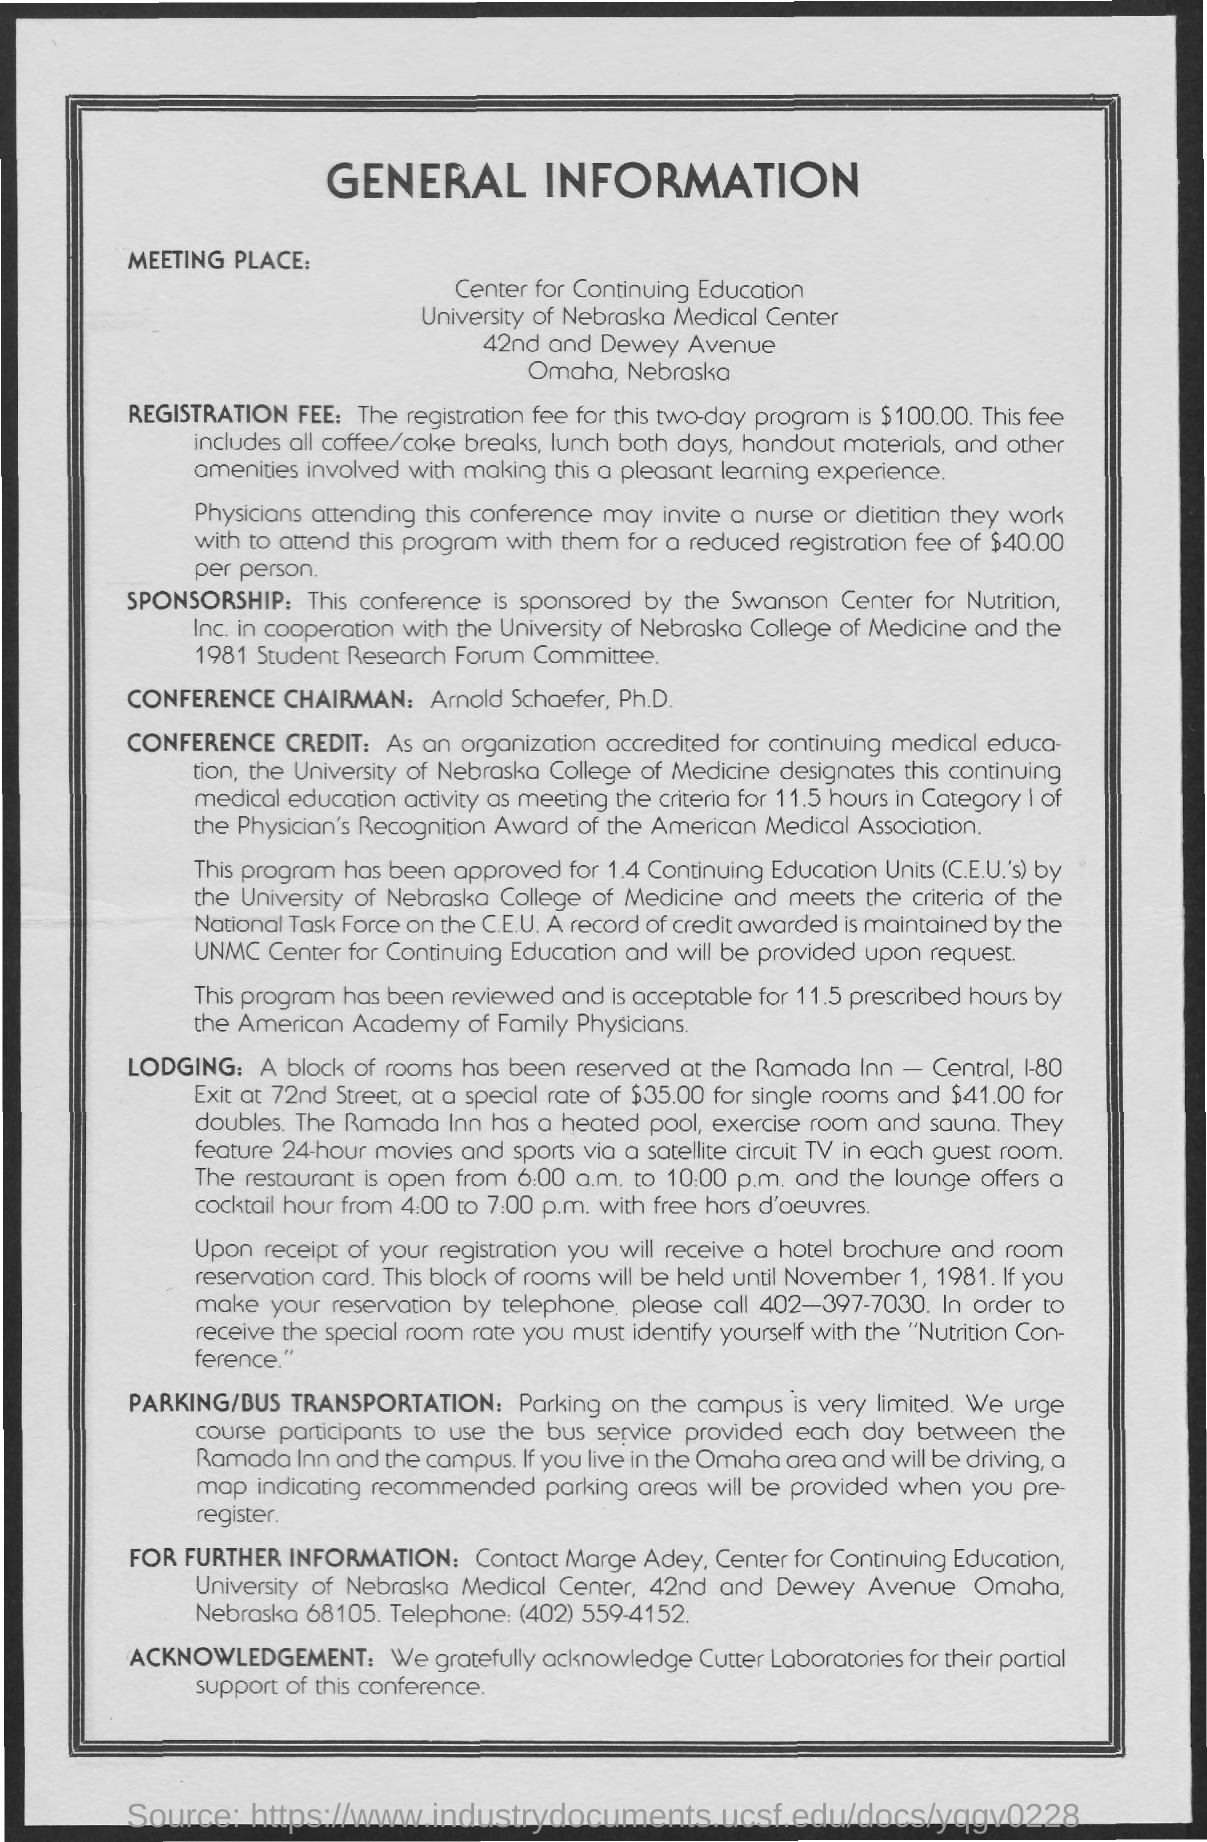Give some essential details in this illustration. To make a reservation by telephone, the contact number is 402-397-7030. The meeting took place in the state of Nebraska in the city of Omaha. The registration fee for the two-day program is $100.00. Arnold Schaefer, Ph.D., is the conference chairman. The special rate for doubles is $41.00. 